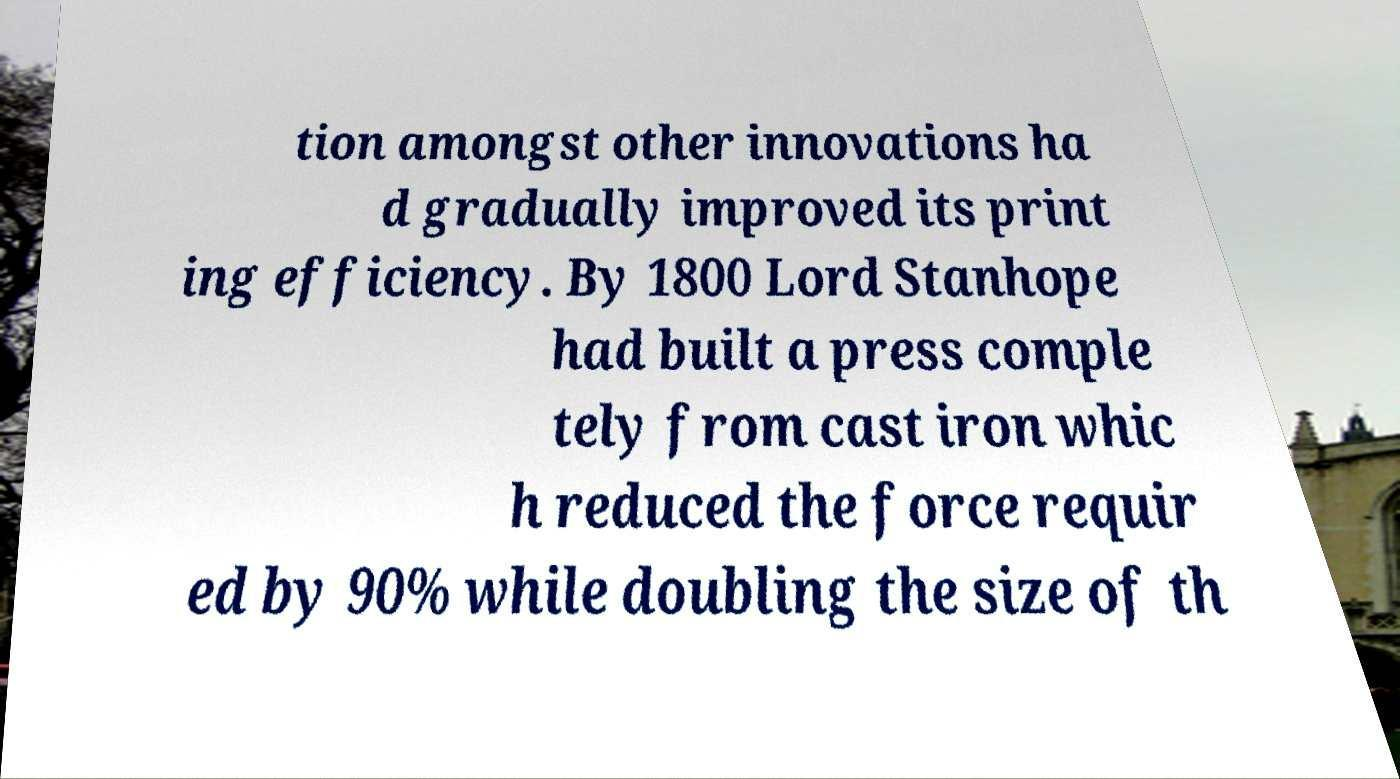Could you assist in decoding the text presented in this image and type it out clearly? tion amongst other innovations ha d gradually improved its print ing efficiency. By 1800 Lord Stanhope had built a press comple tely from cast iron whic h reduced the force requir ed by 90% while doubling the size of th 